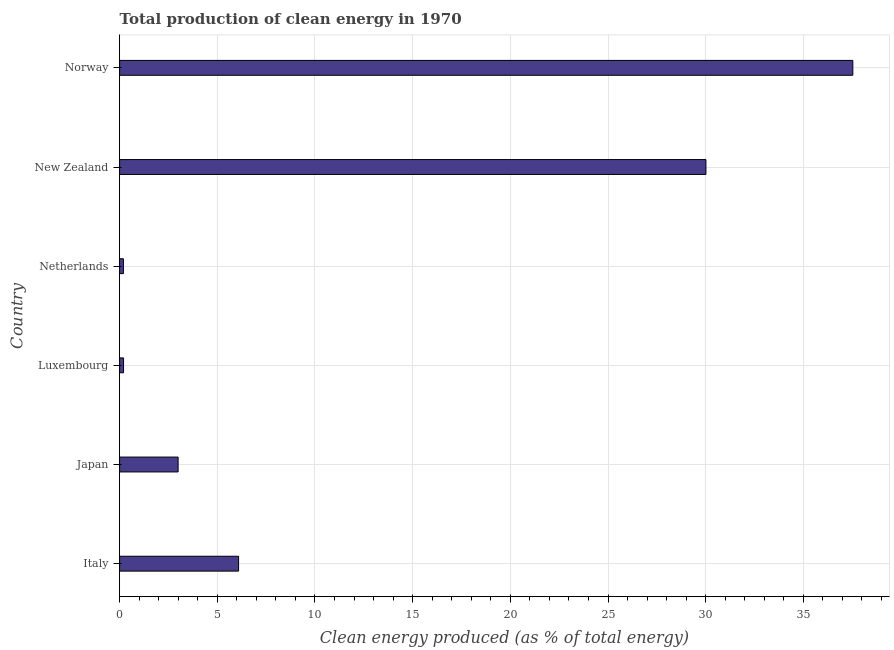Does the graph contain grids?
Provide a short and direct response. Yes. What is the title of the graph?
Keep it short and to the point. Total production of clean energy in 1970. What is the label or title of the X-axis?
Ensure brevity in your answer.  Clean energy produced (as % of total energy). What is the label or title of the Y-axis?
Offer a very short reply. Country. What is the production of clean energy in Netherlands?
Ensure brevity in your answer.  0.2. Across all countries, what is the maximum production of clean energy?
Your response must be concise. 37.53. Across all countries, what is the minimum production of clean energy?
Ensure brevity in your answer.  0.2. In which country was the production of clean energy minimum?
Provide a short and direct response. Netherlands. What is the sum of the production of clean energy?
Offer a very short reply. 77.03. What is the difference between the production of clean energy in Luxembourg and New Zealand?
Provide a succinct answer. -29.81. What is the average production of clean energy per country?
Your response must be concise. 12.84. What is the median production of clean energy?
Provide a short and direct response. 4.54. In how many countries, is the production of clean energy greater than 34 %?
Make the answer very short. 1. What is the ratio of the production of clean energy in Italy to that in Japan?
Provide a succinct answer. 2.03. Is the difference between the production of clean energy in Luxembourg and Norway greater than the difference between any two countries?
Keep it short and to the point. No. What is the difference between the highest and the second highest production of clean energy?
Make the answer very short. 7.52. Is the sum of the production of clean energy in Japan and Norway greater than the maximum production of clean energy across all countries?
Ensure brevity in your answer.  Yes. What is the difference between the highest and the lowest production of clean energy?
Make the answer very short. 37.34. How many bars are there?
Keep it short and to the point. 6. How many countries are there in the graph?
Offer a terse response. 6. Are the values on the major ticks of X-axis written in scientific E-notation?
Ensure brevity in your answer.  No. What is the Clean energy produced (as % of total energy) in Italy?
Offer a very short reply. 6.09. What is the Clean energy produced (as % of total energy) of Japan?
Provide a succinct answer. 3. What is the Clean energy produced (as % of total energy) of Luxembourg?
Your answer should be compact. 0.2. What is the Clean energy produced (as % of total energy) in Netherlands?
Offer a terse response. 0.2. What is the Clean energy produced (as % of total energy) of New Zealand?
Offer a terse response. 30.01. What is the Clean energy produced (as % of total energy) in Norway?
Your response must be concise. 37.53. What is the difference between the Clean energy produced (as % of total energy) in Italy and Japan?
Provide a succinct answer. 3.1. What is the difference between the Clean energy produced (as % of total energy) in Italy and Luxembourg?
Make the answer very short. 5.89. What is the difference between the Clean energy produced (as % of total energy) in Italy and Netherlands?
Offer a very short reply. 5.9. What is the difference between the Clean energy produced (as % of total energy) in Italy and New Zealand?
Your answer should be compact. -23.92. What is the difference between the Clean energy produced (as % of total energy) in Italy and Norway?
Provide a succinct answer. -31.44. What is the difference between the Clean energy produced (as % of total energy) in Japan and Luxembourg?
Your answer should be compact. 2.79. What is the difference between the Clean energy produced (as % of total energy) in Japan and Netherlands?
Provide a short and direct response. 2.8. What is the difference between the Clean energy produced (as % of total energy) in Japan and New Zealand?
Your response must be concise. -27.02. What is the difference between the Clean energy produced (as % of total energy) in Japan and Norway?
Give a very brief answer. -34.54. What is the difference between the Clean energy produced (as % of total energy) in Luxembourg and Netherlands?
Your answer should be compact. 0.01. What is the difference between the Clean energy produced (as % of total energy) in Luxembourg and New Zealand?
Your answer should be very brief. -29.81. What is the difference between the Clean energy produced (as % of total energy) in Luxembourg and Norway?
Provide a succinct answer. -37.33. What is the difference between the Clean energy produced (as % of total energy) in Netherlands and New Zealand?
Offer a terse response. -29.82. What is the difference between the Clean energy produced (as % of total energy) in Netherlands and Norway?
Your answer should be very brief. -37.34. What is the difference between the Clean energy produced (as % of total energy) in New Zealand and Norway?
Your response must be concise. -7.52. What is the ratio of the Clean energy produced (as % of total energy) in Italy to that in Japan?
Provide a succinct answer. 2.03. What is the ratio of the Clean energy produced (as % of total energy) in Italy to that in Luxembourg?
Your answer should be very brief. 30.29. What is the ratio of the Clean energy produced (as % of total energy) in Italy to that in Netherlands?
Offer a terse response. 31.18. What is the ratio of the Clean energy produced (as % of total energy) in Italy to that in New Zealand?
Your answer should be very brief. 0.2. What is the ratio of the Clean energy produced (as % of total energy) in Italy to that in Norway?
Offer a very short reply. 0.16. What is the ratio of the Clean energy produced (as % of total energy) in Japan to that in Luxembourg?
Make the answer very short. 14.9. What is the ratio of the Clean energy produced (as % of total energy) in Japan to that in Netherlands?
Offer a terse response. 15.33. What is the ratio of the Clean energy produced (as % of total energy) in Japan to that in New Zealand?
Make the answer very short. 0.1. What is the ratio of the Clean energy produced (as % of total energy) in Japan to that in Norway?
Keep it short and to the point. 0.08. What is the ratio of the Clean energy produced (as % of total energy) in Luxembourg to that in Netherlands?
Make the answer very short. 1.03. What is the ratio of the Clean energy produced (as % of total energy) in Luxembourg to that in New Zealand?
Offer a terse response. 0.01. What is the ratio of the Clean energy produced (as % of total energy) in Luxembourg to that in Norway?
Offer a very short reply. 0.01. What is the ratio of the Clean energy produced (as % of total energy) in Netherlands to that in New Zealand?
Make the answer very short. 0.01. What is the ratio of the Clean energy produced (as % of total energy) in Netherlands to that in Norway?
Your answer should be very brief. 0.01. 